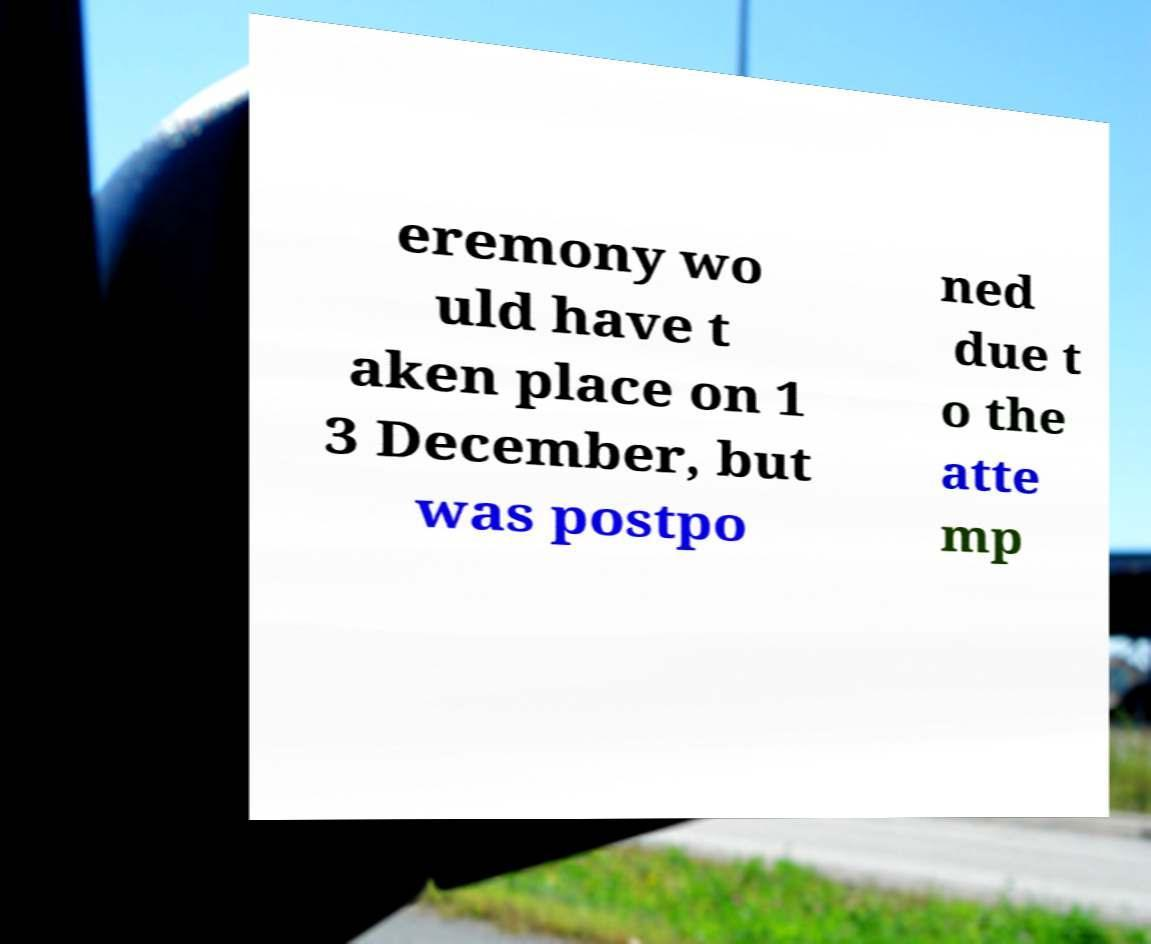For documentation purposes, I need the text within this image transcribed. Could you provide that? eremony wo uld have t aken place on 1 3 December, but was postpo ned due t o the atte mp 